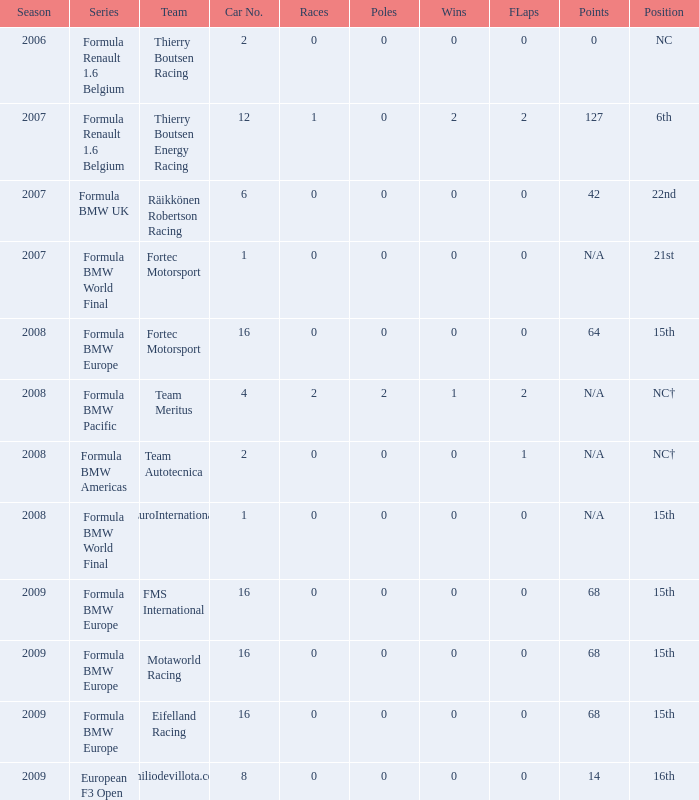Name the series for 68 Formula BMW Europe, Formula BMW Europe, Formula BMW Europe. 